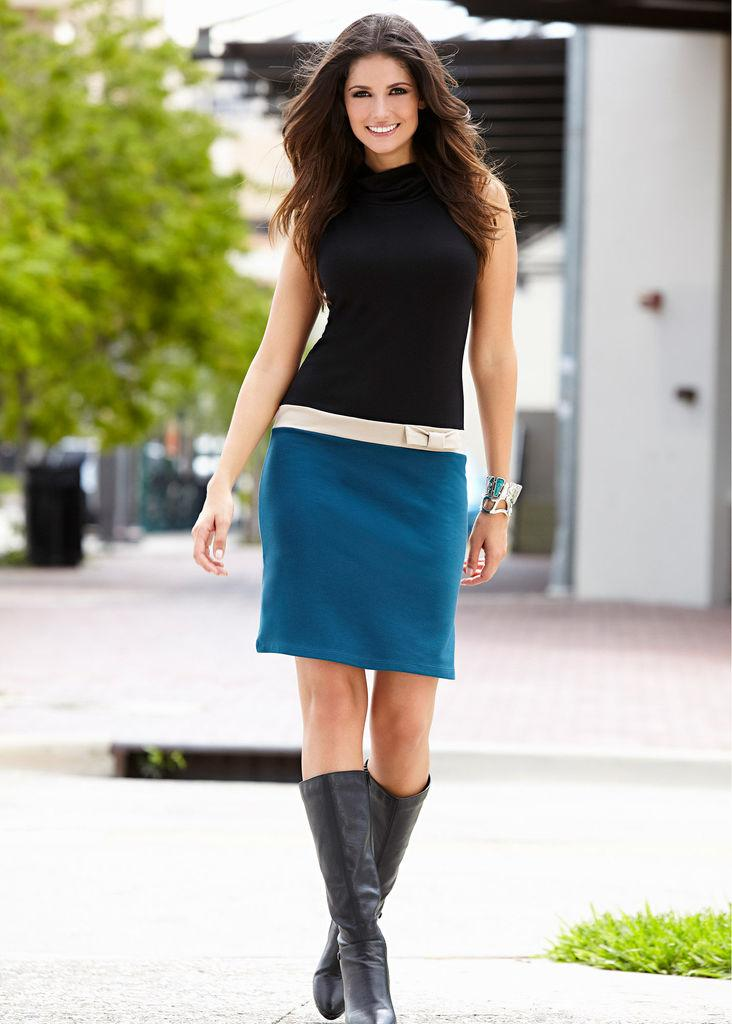Who is present in the image? There is a woman in the image. What is the woman wearing? The woman is wearing a black top and a blue skirt. What is the woman doing in the image? The woman is walking. What can be seen at the bottom of the image? There is a road at the bottom of the image. What is visible in the background of the image? There are trees in the background of the image. What is located to the right of the image? There is a wall to the right of the image. Where is the fireman with a comb in the image? There is no fireman or comb present in the image. 